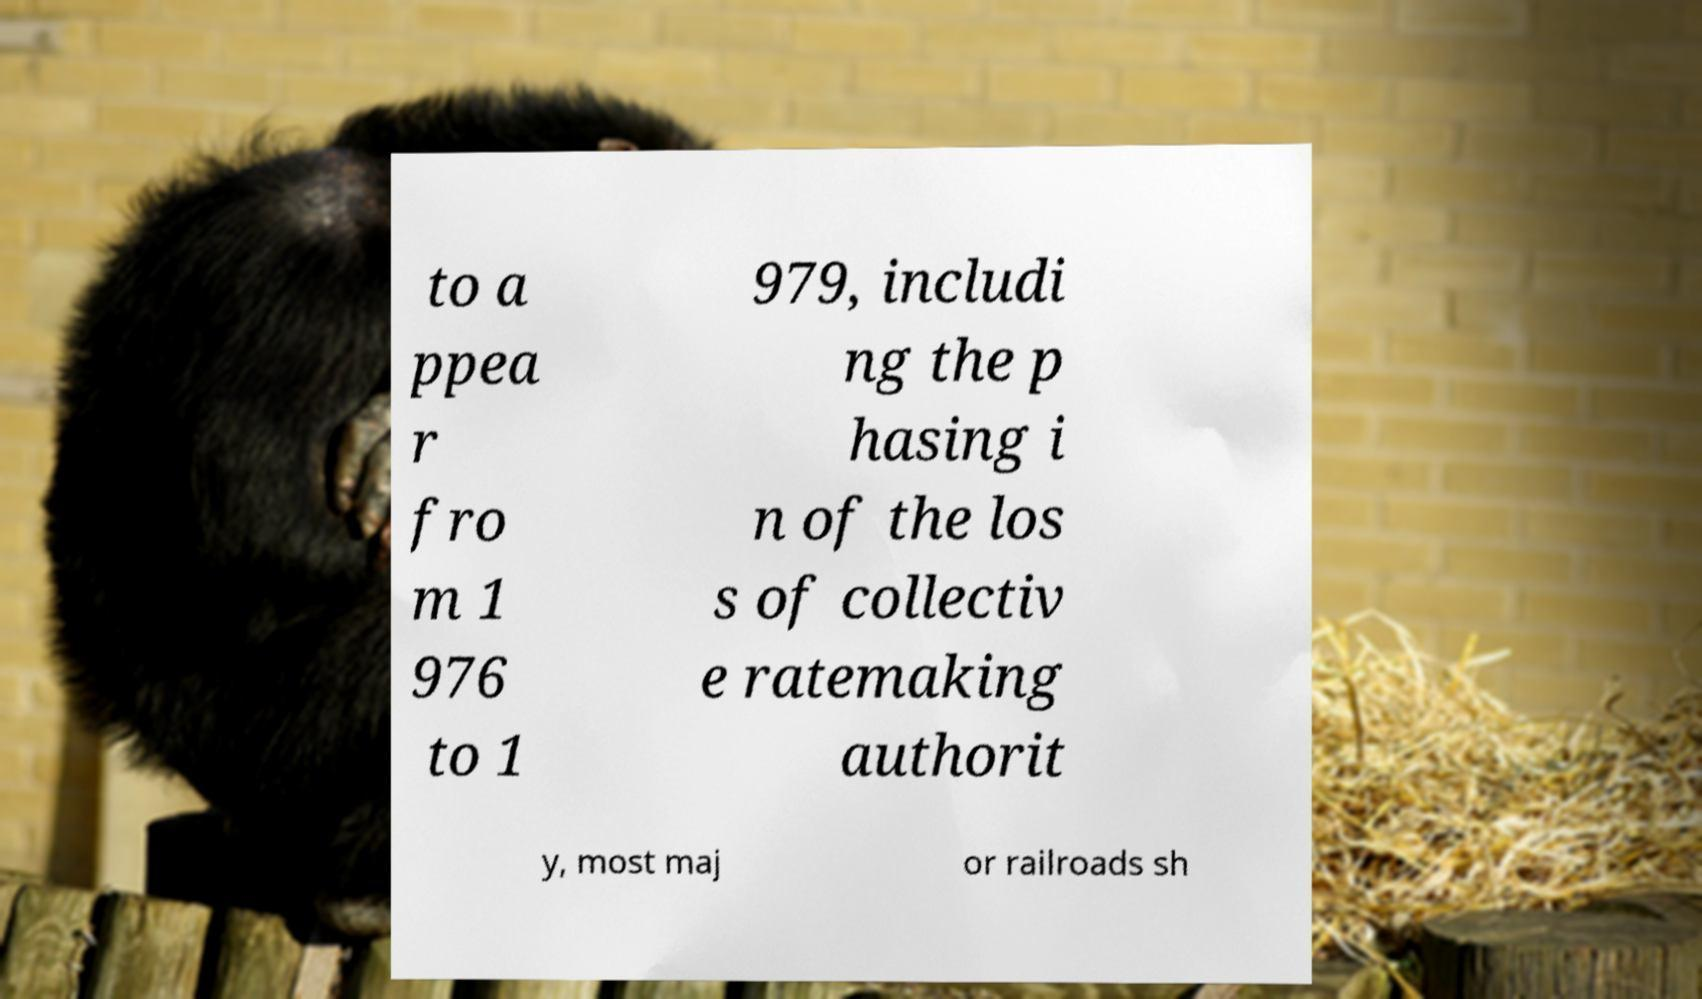Could you assist in decoding the text presented in this image and type it out clearly? to a ppea r fro m 1 976 to 1 979, includi ng the p hasing i n of the los s of collectiv e ratemaking authorit y, most maj or railroads sh 